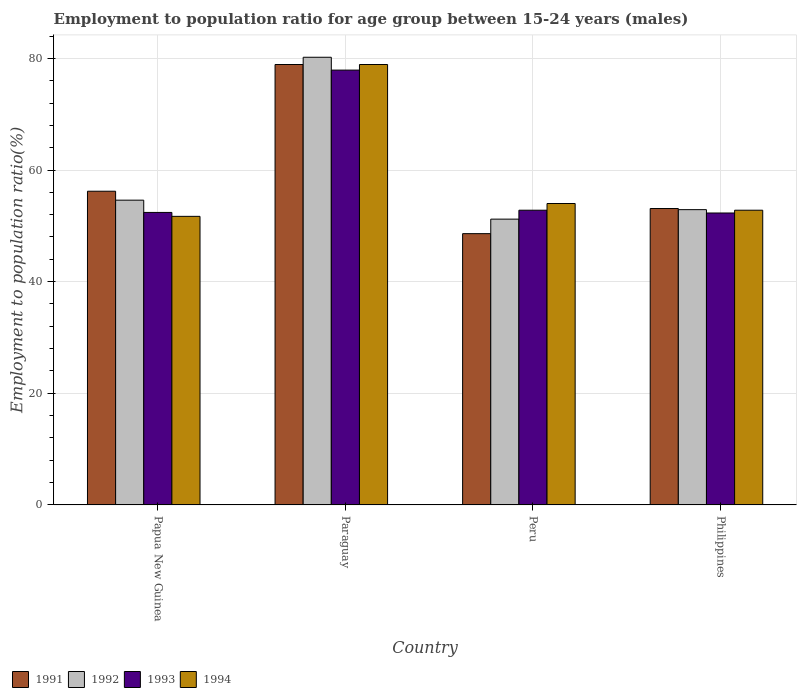How many different coloured bars are there?
Provide a succinct answer. 4. How many groups of bars are there?
Keep it short and to the point. 4. How many bars are there on the 1st tick from the left?
Give a very brief answer. 4. What is the label of the 2nd group of bars from the left?
Provide a short and direct response. Paraguay. What is the employment to population ratio in 1993 in Peru?
Your response must be concise. 52.8. Across all countries, what is the maximum employment to population ratio in 1993?
Give a very brief answer. 77.9. Across all countries, what is the minimum employment to population ratio in 1993?
Your answer should be compact. 52.3. In which country was the employment to population ratio in 1991 maximum?
Keep it short and to the point. Paraguay. What is the total employment to population ratio in 1993 in the graph?
Your answer should be compact. 235.4. What is the difference between the employment to population ratio in 1992 in Paraguay and that in Peru?
Make the answer very short. 29. What is the difference between the employment to population ratio in 1993 in Paraguay and the employment to population ratio in 1992 in Philippines?
Provide a short and direct response. 25. What is the average employment to population ratio in 1994 per country?
Ensure brevity in your answer.  59.35. What is the difference between the employment to population ratio of/in 1994 and employment to population ratio of/in 1993 in Papua New Guinea?
Ensure brevity in your answer.  -0.7. In how many countries, is the employment to population ratio in 1992 greater than 68 %?
Your response must be concise. 1. What is the ratio of the employment to population ratio in 1991 in Papua New Guinea to that in Philippines?
Keep it short and to the point. 1.06. Is the employment to population ratio in 1993 in Papua New Guinea less than that in Paraguay?
Your response must be concise. Yes. Is the difference between the employment to population ratio in 1994 in Papua New Guinea and Philippines greater than the difference between the employment to population ratio in 1993 in Papua New Guinea and Philippines?
Your answer should be compact. No. What is the difference between the highest and the second highest employment to population ratio in 1992?
Offer a very short reply. 27.3. What is the difference between the highest and the lowest employment to population ratio in 1992?
Keep it short and to the point. 29. In how many countries, is the employment to population ratio in 1993 greater than the average employment to population ratio in 1993 taken over all countries?
Offer a very short reply. 1. What does the 4th bar from the right in Papua New Guinea represents?
Your response must be concise. 1991. How many bars are there?
Offer a very short reply. 16. Are all the bars in the graph horizontal?
Offer a terse response. No. What is the difference between two consecutive major ticks on the Y-axis?
Your answer should be very brief. 20. Does the graph contain grids?
Your answer should be very brief. Yes. Where does the legend appear in the graph?
Your answer should be very brief. Bottom left. How many legend labels are there?
Your response must be concise. 4. What is the title of the graph?
Make the answer very short. Employment to population ratio for age group between 15-24 years (males). Does "1964" appear as one of the legend labels in the graph?
Offer a very short reply. No. What is the label or title of the Y-axis?
Provide a short and direct response. Employment to population ratio(%). What is the Employment to population ratio(%) in 1991 in Papua New Guinea?
Keep it short and to the point. 56.2. What is the Employment to population ratio(%) of 1992 in Papua New Guinea?
Make the answer very short. 54.6. What is the Employment to population ratio(%) in 1993 in Papua New Guinea?
Offer a terse response. 52.4. What is the Employment to population ratio(%) of 1994 in Papua New Guinea?
Your answer should be compact. 51.7. What is the Employment to population ratio(%) in 1991 in Paraguay?
Make the answer very short. 78.9. What is the Employment to population ratio(%) in 1992 in Paraguay?
Give a very brief answer. 80.2. What is the Employment to population ratio(%) of 1993 in Paraguay?
Your answer should be very brief. 77.9. What is the Employment to population ratio(%) in 1994 in Paraguay?
Offer a terse response. 78.9. What is the Employment to population ratio(%) of 1991 in Peru?
Provide a short and direct response. 48.6. What is the Employment to population ratio(%) of 1992 in Peru?
Give a very brief answer. 51.2. What is the Employment to population ratio(%) in 1993 in Peru?
Ensure brevity in your answer.  52.8. What is the Employment to population ratio(%) in 1991 in Philippines?
Provide a short and direct response. 53.1. What is the Employment to population ratio(%) in 1992 in Philippines?
Ensure brevity in your answer.  52.9. What is the Employment to population ratio(%) in 1993 in Philippines?
Offer a very short reply. 52.3. What is the Employment to population ratio(%) of 1994 in Philippines?
Your answer should be very brief. 52.8. Across all countries, what is the maximum Employment to population ratio(%) in 1991?
Provide a succinct answer. 78.9. Across all countries, what is the maximum Employment to population ratio(%) in 1992?
Your answer should be compact. 80.2. Across all countries, what is the maximum Employment to population ratio(%) in 1993?
Make the answer very short. 77.9. Across all countries, what is the maximum Employment to population ratio(%) of 1994?
Keep it short and to the point. 78.9. Across all countries, what is the minimum Employment to population ratio(%) of 1991?
Provide a succinct answer. 48.6. Across all countries, what is the minimum Employment to population ratio(%) in 1992?
Your answer should be very brief. 51.2. Across all countries, what is the minimum Employment to population ratio(%) in 1993?
Your response must be concise. 52.3. Across all countries, what is the minimum Employment to population ratio(%) of 1994?
Provide a succinct answer. 51.7. What is the total Employment to population ratio(%) of 1991 in the graph?
Provide a succinct answer. 236.8. What is the total Employment to population ratio(%) of 1992 in the graph?
Your answer should be very brief. 238.9. What is the total Employment to population ratio(%) in 1993 in the graph?
Give a very brief answer. 235.4. What is the total Employment to population ratio(%) of 1994 in the graph?
Offer a terse response. 237.4. What is the difference between the Employment to population ratio(%) of 1991 in Papua New Guinea and that in Paraguay?
Make the answer very short. -22.7. What is the difference between the Employment to population ratio(%) in 1992 in Papua New Guinea and that in Paraguay?
Keep it short and to the point. -25.6. What is the difference between the Employment to population ratio(%) in 1993 in Papua New Guinea and that in Paraguay?
Your response must be concise. -25.5. What is the difference between the Employment to population ratio(%) in 1994 in Papua New Guinea and that in Paraguay?
Keep it short and to the point. -27.2. What is the difference between the Employment to population ratio(%) of 1991 in Papua New Guinea and that in Philippines?
Your answer should be compact. 3.1. What is the difference between the Employment to population ratio(%) of 1994 in Papua New Guinea and that in Philippines?
Make the answer very short. -1.1. What is the difference between the Employment to population ratio(%) of 1991 in Paraguay and that in Peru?
Offer a very short reply. 30.3. What is the difference between the Employment to population ratio(%) in 1992 in Paraguay and that in Peru?
Give a very brief answer. 29. What is the difference between the Employment to population ratio(%) in 1993 in Paraguay and that in Peru?
Give a very brief answer. 25.1. What is the difference between the Employment to population ratio(%) of 1994 in Paraguay and that in Peru?
Give a very brief answer. 24.9. What is the difference between the Employment to population ratio(%) in 1991 in Paraguay and that in Philippines?
Your answer should be compact. 25.8. What is the difference between the Employment to population ratio(%) in 1992 in Paraguay and that in Philippines?
Give a very brief answer. 27.3. What is the difference between the Employment to population ratio(%) of 1993 in Paraguay and that in Philippines?
Your answer should be very brief. 25.6. What is the difference between the Employment to population ratio(%) of 1994 in Paraguay and that in Philippines?
Make the answer very short. 26.1. What is the difference between the Employment to population ratio(%) in 1992 in Peru and that in Philippines?
Provide a succinct answer. -1.7. What is the difference between the Employment to population ratio(%) of 1994 in Peru and that in Philippines?
Offer a very short reply. 1.2. What is the difference between the Employment to population ratio(%) in 1991 in Papua New Guinea and the Employment to population ratio(%) in 1993 in Paraguay?
Ensure brevity in your answer.  -21.7. What is the difference between the Employment to population ratio(%) in 1991 in Papua New Guinea and the Employment to population ratio(%) in 1994 in Paraguay?
Provide a succinct answer. -22.7. What is the difference between the Employment to population ratio(%) of 1992 in Papua New Guinea and the Employment to population ratio(%) of 1993 in Paraguay?
Make the answer very short. -23.3. What is the difference between the Employment to population ratio(%) of 1992 in Papua New Guinea and the Employment to population ratio(%) of 1994 in Paraguay?
Ensure brevity in your answer.  -24.3. What is the difference between the Employment to population ratio(%) of 1993 in Papua New Guinea and the Employment to population ratio(%) of 1994 in Paraguay?
Offer a very short reply. -26.5. What is the difference between the Employment to population ratio(%) of 1991 in Papua New Guinea and the Employment to population ratio(%) of 1994 in Peru?
Offer a very short reply. 2.2. What is the difference between the Employment to population ratio(%) in 1992 in Papua New Guinea and the Employment to population ratio(%) in 1994 in Peru?
Your answer should be very brief. 0.6. What is the difference between the Employment to population ratio(%) of 1993 in Papua New Guinea and the Employment to population ratio(%) of 1994 in Peru?
Your response must be concise. -1.6. What is the difference between the Employment to population ratio(%) in 1991 in Papua New Guinea and the Employment to population ratio(%) in 1992 in Philippines?
Your response must be concise. 3.3. What is the difference between the Employment to population ratio(%) of 1991 in Papua New Guinea and the Employment to population ratio(%) of 1993 in Philippines?
Provide a succinct answer. 3.9. What is the difference between the Employment to population ratio(%) of 1992 in Papua New Guinea and the Employment to population ratio(%) of 1993 in Philippines?
Offer a very short reply. 2.3. What is the difference between the Employment to population ratio(%) of 1991 in Paraguay and the Employment to population ratio(%) of 1992 in Peru?
Keep it short and to the point. 27.7. What is the difference between the Employment to population ratio(%) of 1991 in Paraguay and the Employment to population ratio(%) of 1993 in Peru?
Your response must be concise. 26.1. What is the difference between the Employment to population ratio(%) in 1991 in Paraguay and the Employment to population ratio(%) in 1994 in Peru?
Keep it short and to the point. 24.9. What is the difference between the Employment to population ratio(%) of 1992 in Paraguay and the Employment to population ratio(%) of 1993 in Peru?
Your response must be concise. 27.4. What is the difference between the Employment to population ratio(%) of 1992 in Paraguay and the Employment to population ratio(%) of 1994 in Peru?
Offer a very short reply. 26.2. What is the difference between the Employment to population ratio(%) of 1993 in Paraguay and the Employment to population ratio(%) of 1994 in Peru?
Provide a succinct answer. 23.9. What is the difference between the Employment to population ratio(%) of 1991 in Paraguay and the Employment to population ratio(%) of 1992 in Philippines?
Make the answer very short. 26. What is the difference between the Employment to population ratio(%) of 1991 in Paraguay and the Employment to population ratio(%) of 1993 in Philippines?
Your answer should be very brief. 26.6. What is the difference between the Employment to population ratio(%) in 1991 in Paraguay and the Employment to population ratio(%) in 1994 in Philippines?
Offer a very short reply. 26.1. What is the difference between the Employment to population ratio(%) of 1992 in Paraguay and the Employment to population ratio(%) of 1993 in Philippines?
Ensure brevity in your answer.  27.9. What is the difference between the Employment to population ratio(%) in 1992 in Paraguay and the Employment to population ratio(%) in 1994 in Philippines?
Offer a terse response. 27.4. What is the difference between the Employment to population ratio(%) in 1993 in Paraguay and the Employment to population ratio(%) in 1994 in Philippines?
Your answer should be very brief. 25.1. What is the difference between the Employment to population ratio(%) of 1991 in Peru and the Employment to population ratio(%) of 1994 in Philippines?
Make the answer very short. -4.2. What is the difference between the Employment to population ratio(%) in 1992 in Peru and the Employment to population ratio(%) in 1993 in Philippines?
Provide a short and direct response. -1.1. What is the difference between the Employment to population ratio(%) in 1992 in Peru and the Employment to population ratio(%) in 1994 in Philippines?
Your response must be concise. -1.6. What is the average Employment to population ratio(%) of 1991 per country?
Keep it short and to the point. 59.2. What is the average Employment to population ratio(%) of 1992 per country?
Keep it short and to the point. 59.73. What is the average Employment to population ratio(%) of 1993 per country?
Offer a very short reply. 58.85. What is the average Employment to population ratio(%) in 1994 per country?
Your response must be concise. 59.35. What is the difference between the Employment to population ratio(%) in 1991 and Employment to population ratio(%) in 1992 in Papua New Guinea?
Make the answer very short. 1.6. What is the difference between the Employment to population ratio(%) of 1991 and Employment to population ratio(%) of 1992 in Paraguay?
Your response must be concise. -1.3. What is the difference between the Employment to population ratio(%) of 1991 and Employment to population ratio(%) of 1994 in Paraguay?
Offer a terse response. 0. What is the difference between the Employment to population ratio(%) of 1992 and Employment to population ratio(%) of 1993 in Paraguay?
Offer a terse response. 2.3. What is the difference between the Employment to population ratio(%) in 1992 and Employment to population ratio(%) in 1994 in Paraguay?
Offer a terse response. 1.3. What is the difference between the Employment to population ratio(%) in 1993 and Employment to population ratio(%) in 1994 in Paraguay?
Offer a very short reply. -1. What is the difference between the Employment to population ratio(%) of 1992 and Employment to population ratio(%) of 1993 in Peru?
Provide a short and direct response. -1.6. What is the difference between the Employment to population ratio(%) in 1993 and Employment to population ratio(%) in 1994 in Peru?
Make the answer very short. -1.2. What is the difference between the Employment to population ratio(%) in 1991 and Employment to population ratio(%) in 1992 in Philippines?
Offer a terse response. 0.2. What is the difference between the Employment to population ratio(%) of 1991 and Employment to population ratio(%) of 1993 in Philippines?
Your response must be concise. 0.8. What is the difference between the Employment to population ratio(%) of 1992 and Employment to population ratio(%) of 1994 in Philippines?
Give a very brief answer. 0.1. What is the difference between the Employment to population ratio(%) in 1993 and Employment to population ratio(%) in 1994 in Philippines?
Offer a very short reply. -0.5. What is the ratio of the Employment to population ratio(%) in 1991 in Papua New Guinea to that in Paraguay?
Offer a terse response. 0.71. What is the ratio of the Employment to population ratio(%) of 1992 in Papua New Guinea to that in Paraguay?
Offer a very short reply. 0.68. What is the ratio of the Employment to population ratio(%) in 1993 in Papua New Guinea to that in Paraguay?
Give a very brief answer. 0.67. What is the ratio of the Employment to population ratio(%) in 1994 in Papua New Guinea to that in Paraguay?
Your answer should be very brief. 0.66. What is the ratio of the Employment to population ratio(%) in 1991 in Papua New Guinea to that in Peru?
Make the answer very short. 1.16. What is the ratio of the Employment to population ratio(%) of 1992 in Papua New Guinea to that in Peru?
Make the answer very short. 1.07. What is the ratio of the Employment to population ratio(%) of 1993 in Papua New Guinea to that in Peru?
Keep it short and to the point. 0.99. What is the ratio of the Employment to population ratio(%) of 1994 in Papua New Guinea to that in Peru?
Give a very brief answer. 0.96. What is the ratio of the Employment to population ratio(%) of 1991 in Papua New Guinea to that in Philippines?
Your answer should be very brief. 1.06. What is the ratio of the Employment to population ratio(%) in 1992 in Papua New Guinea to that in Philippines?
Ensure brevity in your answer.  1.03. What is the ratio of the Employment to population ratio(%) of 1993 in Papua New Guinea to that in Philippines?
Offer a terse response. 1. What is the ratio of the Employment to population ratio(%) in 1994 in Papua New Guinea to that in Philippines?
Your answer should be very brief. 0.98. What is the ratio of the Employment to population ratio(%) in 1991 in Paraguay to that in Peru?
Offer a very short reply. 1.62. What is the ratio of the Employment to population ratio(%) of 1992 in Paraguay to that in Peru?
Ensure brevity in your answer.  1.57. What is the ratio of the Employment to population ratio(%) in 1993 in Paraguay to that in Peru?
Offer a terse response. 1.48. What is the ratio of the Employment to population ratio(%) of 1994 in Paraguay to that in Peru?
Make the answer very short. 1.46. What is the ratio of the Employment to population ratio(%) of 1991 in Paraguay to that in Philippines?
Offer a terse response. 1.49. What is the ratio of the Employment to population ratio(%) of 1992 in Paraguay to that in Philippines?
Give a very brief answer. 1.52. What is the ratio of the Employment to population ratio(%) in 1993 in Paraguay to that in Philippines?
Offer a very short reply. 1.49. What is the ratio of the Employment to population ratio(%) of 1994 in Paraguay to that in Philippines?
Make the answer very short. 1.49. What is the ratio of the Employment to population ratio(%) in 1991 in Peru to that in Philippines?
Give a very brief answer. 0.92. What is the ratio of the Employment to population ratio(%) of 1992 in Peru to that in Philippines?
Keep it short and to the point. 0.97. What is the ratio of the Employment to population ratio(%) in 1993 in Peru to that in Philippines?
Your response must be concise. 1.01. What is the ratio of the Employment to population ratio(%) of 1994 in Peru to that in Philippines?
Your answer should be very brief. 1.02. What is the difference between the highest and the second highest Employment to population ratio(%) in 1991?
Provide a short and direct response. 22.7. What is the difference between the highest and the second highest Employment to population ratio(%) of 1992?
Keep it short and to the point. 25.6. What is the difference between the highest and the second highest Employment to population ratio(%) of 1993?
Offer a very short reply. 25.1. What is the difference between the highest and the second highest Employment to population ratio(%) of 1994?
Your answer should be very brief. 24.9. What is the difference between the highest and the lowest Employment to population ratio(%) of 1991?
Ensure brevity in your answer.  30.3. What is the difference between the highest and the lowest Employment to population ratio(%) of 1993?
Provide a short and direct response. 25.6. What is the difference between the highest and the lowest Employment to population ratio(%) of 1994?
Offer a terse response. 27.2. 